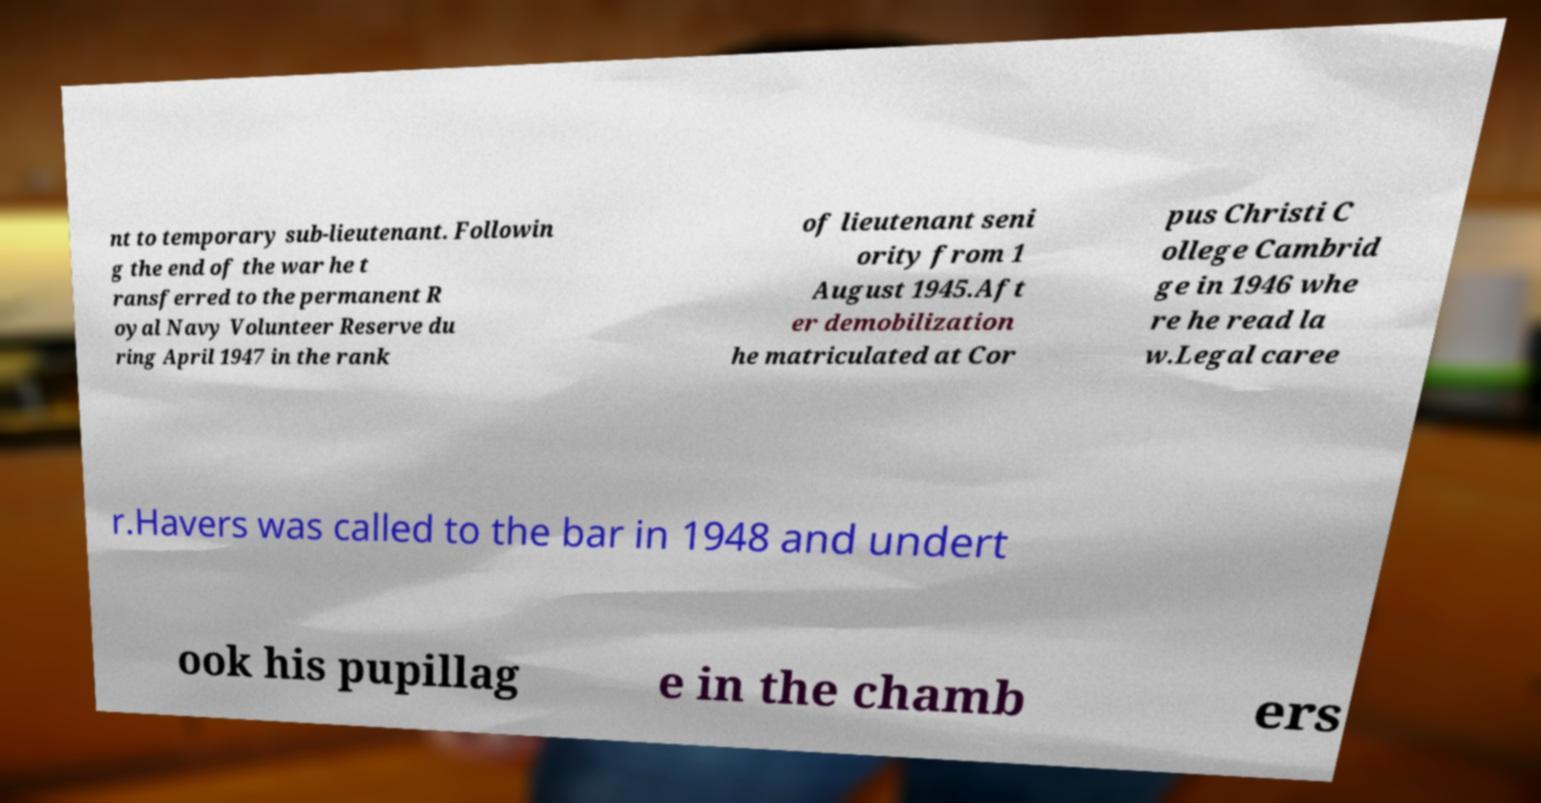Could you assist in decoding the text presented in this image and type it out clearly? nt to temporary sub-lieutenant. Followin g the end of the war he t ransferred to the permanent R oyal Navy Volunteer Reserve du ring April 1947 in the rank of lieutenant seni ority from 1 August 1945.Aft er demobilization he matriculated at Cor pus Christi C ollege Cambrid ge in 1946 whe re he read la w.Legal caree r.Havers was called to the bar in 1948 and undert ook his pupillag e in the chamb ers 